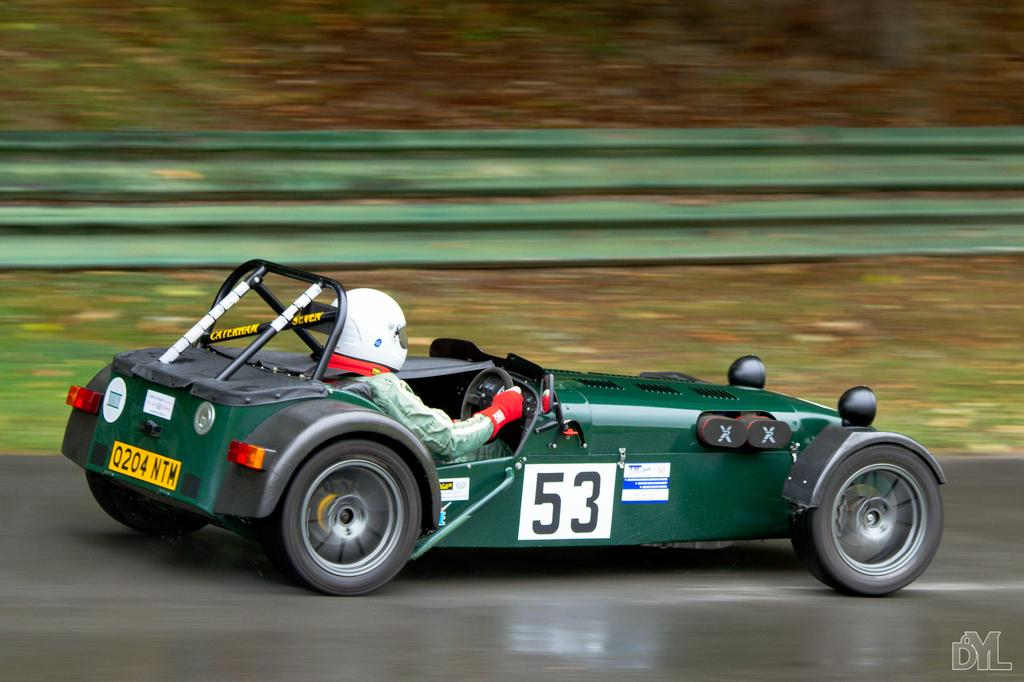What is the person in the image doing? There is a person driving a car in the image. What safety precaution is the person taking while driving? The person is wearing a helmet. Can you describe any additional details about the image? There is a logo at the right bottom of the image. What can be seen in the background of the image? There is grass in the background of the image. How many beans are visible in the image? There are no beans present in the image. What type of birth is depicted in the image? There is no birth depicted in the image; it features a person driving a car. 